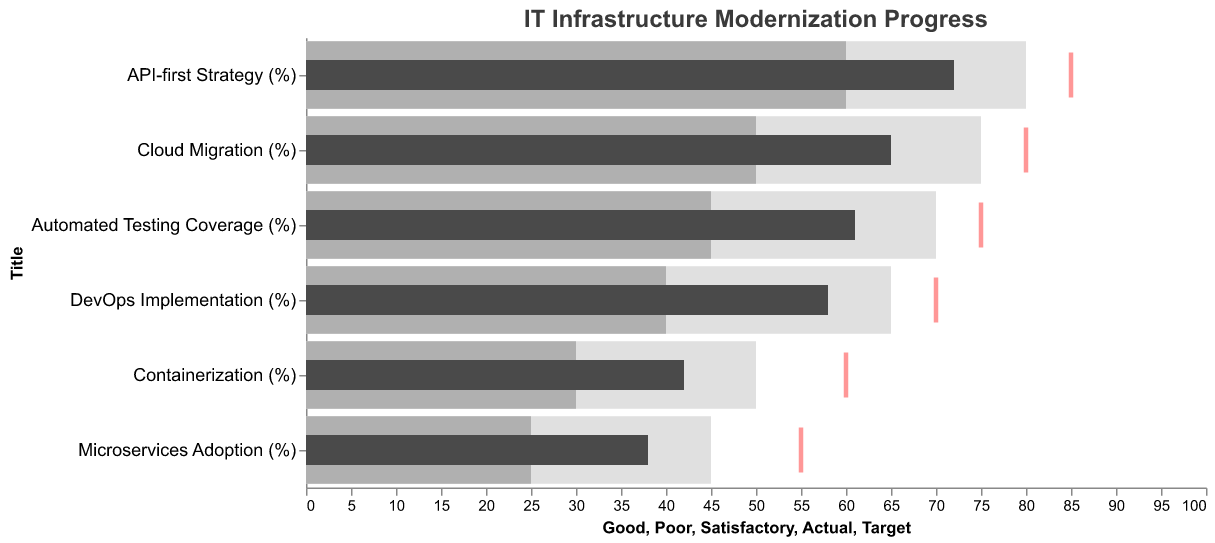What's the title of the figure? The title is displayed at the top of the chart in a larger font size.
Answer: IT Infrastructure Modernization Progress Which metric has the highest actual progress? By looking at the highest bar in the chart relative to the "Actual" progress, we can identify the metric with the highest value.
Answer: API-first Strategy (%) Are there any metrics where the actual progress exceeds the "Good" threshold? Comparing the actual progress bars with the "Good" threshold for each metric reveals that none of the actual progress bars exceeds the "Good" threshold.
Answer: No Which metric has the smallest gap between actual progress and target? Find the difference between the actual progress and target for each metric, and identify the smallest difference.
Answer: API-first Strategy (%) What percentage of cloud migration progress have we achieved compared to the target? Calculate the percentage of the actual cloud migration progress relative to its target: (Actual / Target) * 100.
Answer: 81.25% How many metrics are there in total? Count the number of distinct metrics listed in the chart.
Answer: 6 Which metric is closest to reaching the "Good" threshold? Compare the actual progress of each metric to the "Good" threshold and find the one closest to it.
Answer: API-first Strategy (%) What's the average target percentage across all metrics? Sum up all target percentages and divide by the number of metrics.
Answer: 70.83% What's the largest deviation between satisfactory and target levels among all metrics? Subtract the Satisfactory value from the Target value for each metric, and identify the largest of these differences.
Answer: API-first Strategy (%) Which metrics have actual progress below the "Satisfactory" level? Identify the metrics where the actual progress bar does not reach the "Satisfactory" threshold.
Answer: Containerization (%), Microservices Adoption (%) 